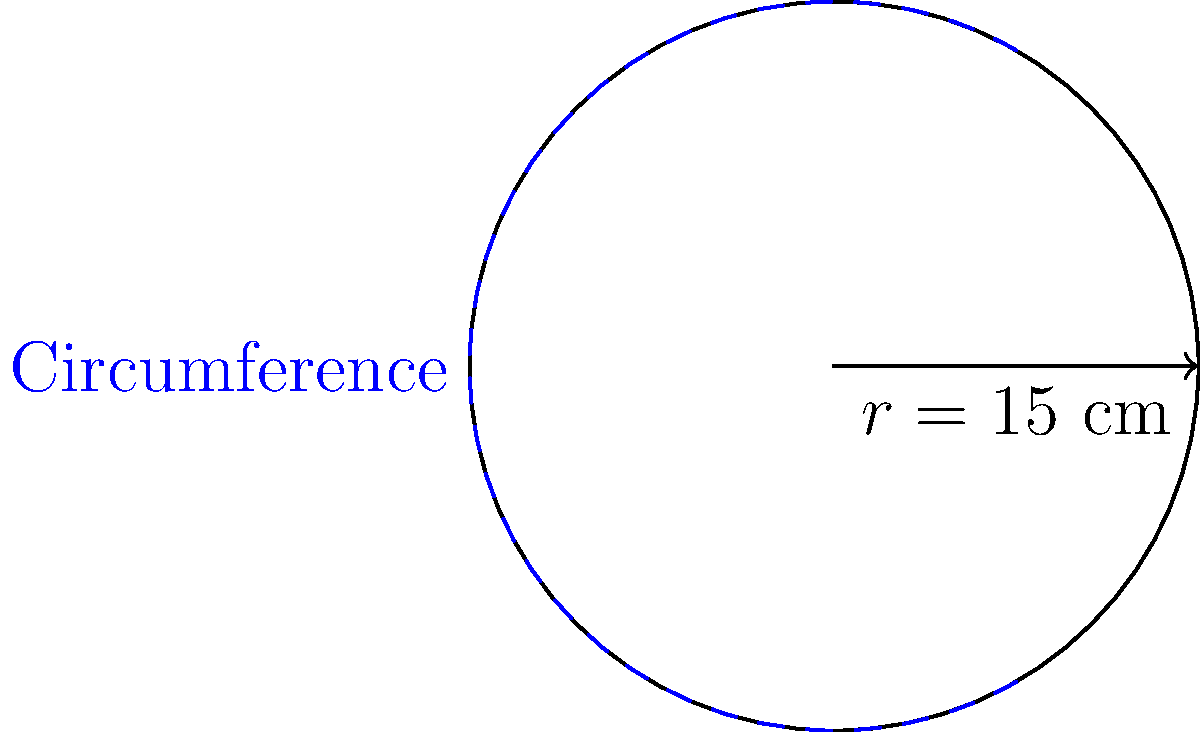As a tournament director, you're designing a circular trophy base for the championship. If the radius of the base is 15 cm, what is the circumference of the trophy base? Use $\pi \approx 3.14$ for your calculations. To find the circumference of a circular trophy base, we can use the formula:

$$C = 2\pi r$$

Where:
$C$ = circumference
$\pi$ ≈ 3.14 (given approximation)
$r$ = radius = 15 cm

Let's substitute these values into the formula:

$$C = 2 \times 3.14 \times 15$$

Now, let's calculate:

1) First, multiply 3.14 by 15:
   $3.14 \times 15 = 47.1$

2) Then, multiply the result by 2:
   $2 \times 47.1 = 94.2$

Therefore, the circumference of the trophy base is 94.2 cm.
Answer: 94.2 cm 